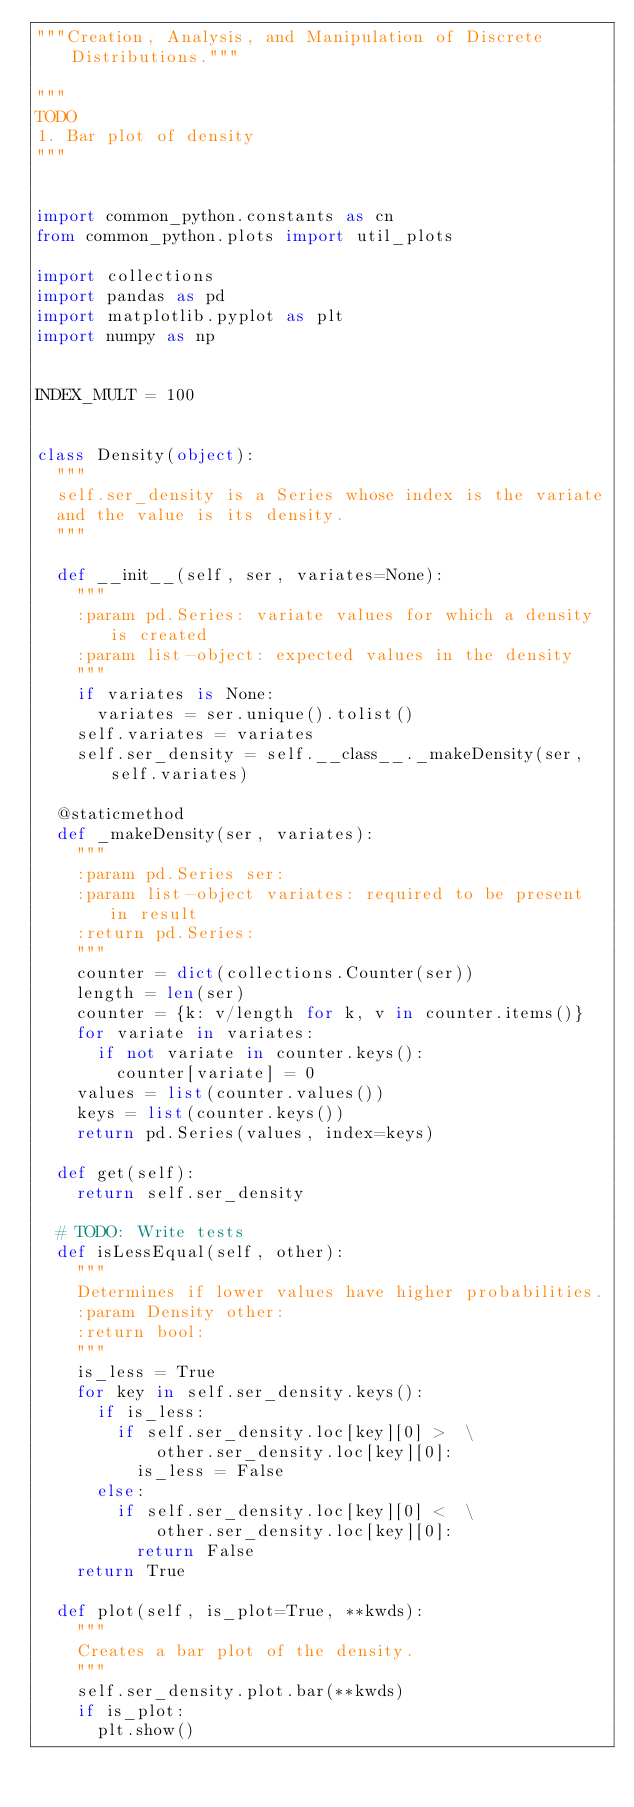<code> <loc_0><loc_0><loc_500><loc_500><_Python_>"""Creation, Analysis, and Manipulation of Discrete Distributions."""

"""
TODO
1. Bar plot of density
"""


import common_python.constants as cn
from common_python.plots import util_plots

import collections
import pandas as pd
import matplotlib.pyplot as plt
import numpy as np


INDEX_MULT = 100


class Density(object):
  """
  self.ser_density is a Series whose index is the variate
  and the value is its density.
  """

  def __init__(self, ser, variates=None):
    """
    :param pd.Series: variate values for which a density is created
    :param list-object: expected values in the density
    """
    if variates is None:
      variates = ser.unique().tolist()
    self.variates = variates
    self.ser_density = self.__class__._makeDensity(ser, self.variates)

  @staticmethod
  def _makeDensity(ser, variates):
    """
    :param pd.Series ser:
    :param list-object variates: required to be present in result
    :return pd.Series:
    """
    counter = dict(collections.Counter(ser))
    length = len(ser)
    counter = {k: v/length for k, v in counter.items()}
    for variate in variates:
      if not variate in counter.keys():
        counter[variate] = 0
    values = list(counter.values())
    keys = list(counter.keys())
    return pd.Series(values, index=keys)

  def get(self):
    return self.ser_density

  # TODO: Write tests
  def isLessEqual(self, other):
    """
    Determines if lower values have higher probabilities.
    :param Density other:
    :return bool:
    """
    is_less = True
    for key in self.ser_density.keys():
      if is_less:
        if self.ser_density.loc[key][0] >  \
            other.ser_density.loc[key][0]:
          is_less = False
      else:
        if self.ser_density.loc[key][0] <  \
            other.ser_density.loc[key][0]:
          return False
    return True

  def plot(self, is_plot=True, **kwds):
    """
    Creates a bar plot of the density.
    """
    self.ser_density.plot.bar(**kwds)
    if is_plot:
      plt.show()
</code> 